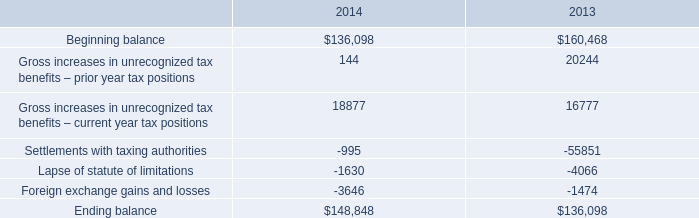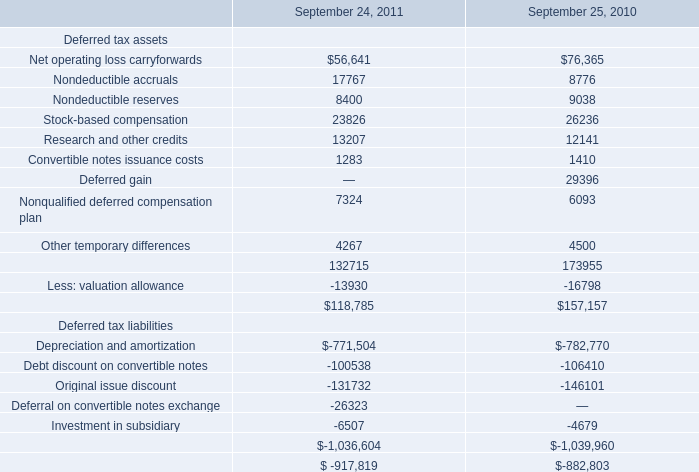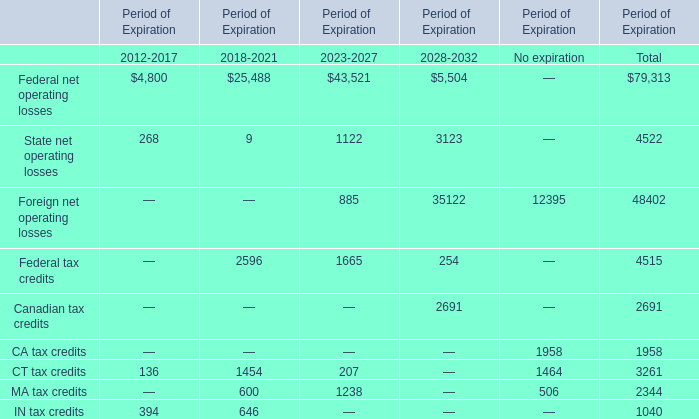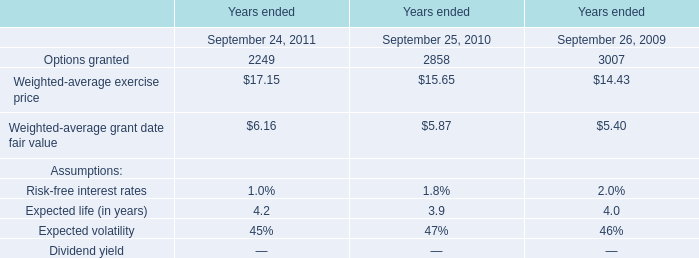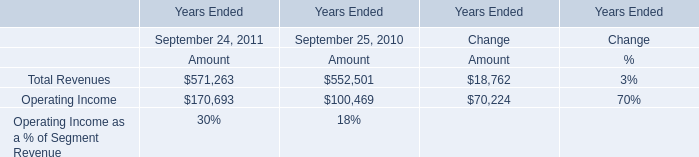What was the total amount of elements greater than 200 for 2012-2017? 
Computations: ((4800 + 268) + 394)
Answer: 5462.0. 